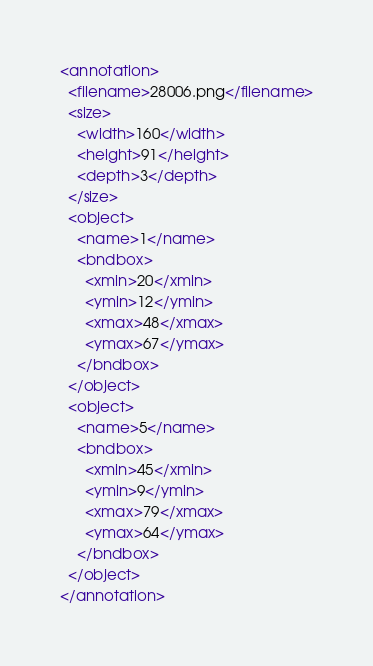<code> <loc_0><loc_0><loc_500><loc_500><_XML_><annotation>
  <filename>28006.png</filename>
  <size>
    <width>160</width>
    <height>91</height>
    <depth>3</depth>
  </size>
  <object>
    <name>1</name>
    <bndbox>
      <xmin>20</xmin>
      <ymin>12</ymin>
      <xmax>48</xmax>
      <ymax>67</ymax>
    </bndbox>
  </object>
  <object>
    <name>5</name>
    <bndbox>
      <xmin>45</xmin>
      <ymin>9</ymin>
      <xmax>79</xmax>
      <ymax>64</ymax>
    </bndbox>
  </object>
</annotation>
</code> 